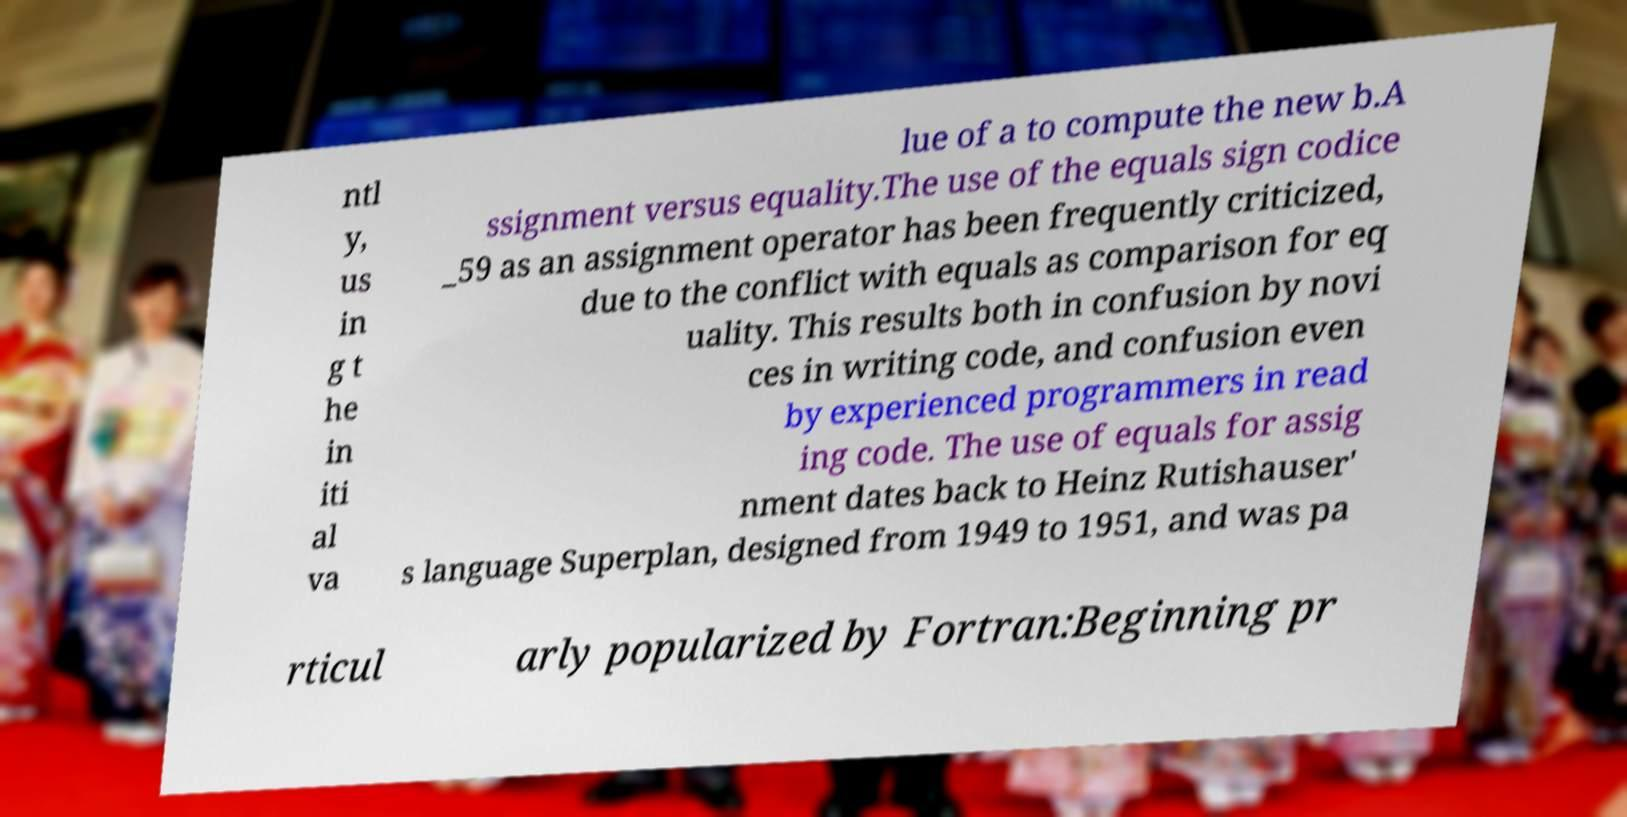For documentation purposes, I need the text within this image transcribed. Could you provide that? ntl y, us in g t he in iti al va lue of a to compute the new b.A ssignment versus equality.The use of the equals sign codice _59 as an assignment operator has been frequently criticized, due to the conflict with equals as comparison for eq uality. This results both in confusion by novi ces in writing code, and confusion even by experienced programmers in read ing code. The use of equals for assig nment dates back to Heinz Rutishauser' s language Superplan, designed from 1949 to 1951, and was pa rticul arly popularized by Fortran:Beginning pr 